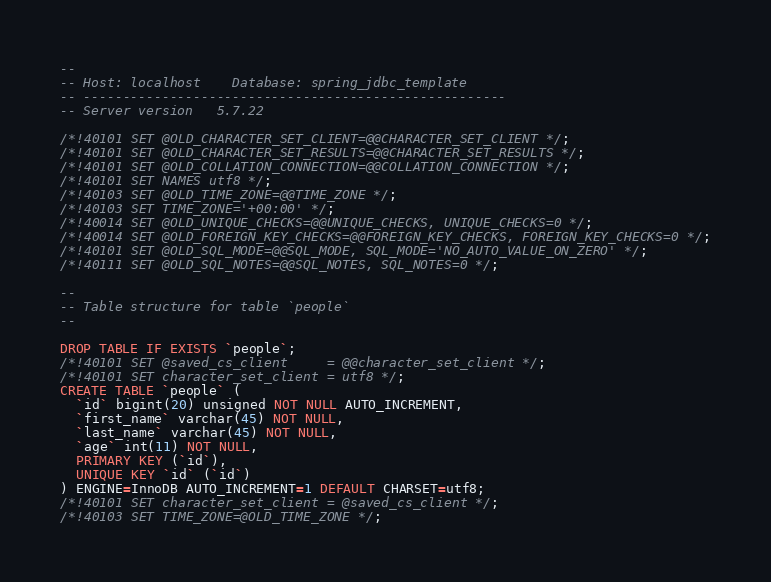<code> <loc_0><loc_0><loc_500><loc_500><_SQL_>--
-- Host: localhost    Database: spring_jdbc_template
-- ------------------------------------------------------
-- Server version	5.7.22

/*!40101 SET @OLD_CHARACTER_SET_CLIENT=@@CHARACTER_SET_CLIENT */;
/*!40101 SET @OLD_CHARACTER_SET_RESULTS=@@CHARACTER_SET_RESULTS */;
/*!40101 SET @OLD_COLLATION_CONNECTION=@@COLLATION_CONNECTION */;
/*!40101 SET NAMES utf8 */;
/*!40103 SET @OLD_TIME_ZONE=@@TIME_ZONE */;
/*!40103 SET TIME_ZONE='+00:00' */;
/*!40014 SET @OLD_UNIQUE_CHECKS=@@UNIQUE_CHECKS, UNIQUE_CHECKS=0 */;
/*!40014 SET @OLD_FOREIGN_KEY_CHECKS=@@FOREIGN_KEY_CHECKS, FOREIGN_KEY_CHECKS=0 */;
/*!40101 SET @OLD_SQL_MODE=@@SQL_MODE, SQL_MODE='NO_AUTO_VALUE_ON_ZERO' */;
/*!40111 SET @OLD_SQL_NOTES=@@SQL_NOTES, SQL_NOTES=0 */;

--
-- Table structure for table `people`
--

DROP TABLE IF EXISTS `people`;
/*!40101 SET @saved_cs_client     = @@character_set_client */;
/*!40101 SET character_set_client = utf8 */;
CREATE TABLE `people` (
  `id` bigint(20) unsigned NOT NULL AUTO_INCREMENT,
  `first_name` varchar(45) NOT NULL,
  `last_name` varchar(45) NOT NULL,
  `age` int(11) NOT NULL,
  PRIMARY KEY (`id`),
  UNIQUE KEY `id` (`id`)
) ENGINE=InnoDB AUTO_INCREMENT=1 DEFAULT CHARSET=utf8;
/*!40101 SET character_set_client = @saved_cs_client */;
/*!40103 SET TIME_ZONE=@OLD_TIME_ZONE */;
</code> 